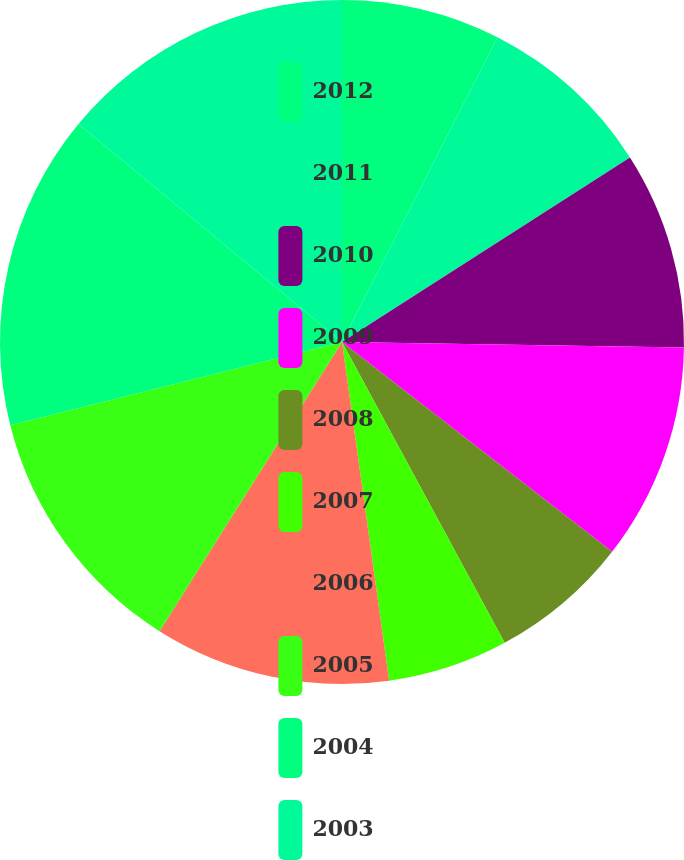<chart> <loc_0><loc_0><loc_500><loc_500><pie_chart><fcel>2012<fcel>2011<fcel>2010<fcel>2009<fcel>2008<fcel>2007<fcel>2006<fcel>2005<fcel>2004<fcel>2003<nl><fcel>7.51%<fcel>8.42%<fcel>9.33%<fcel>10.25%<fcel>6.6%<fcel>5.69%<fcel>11.16%<fcel>12.13%<fcel>14.91%<fcel>14.0%<nl></chart> 